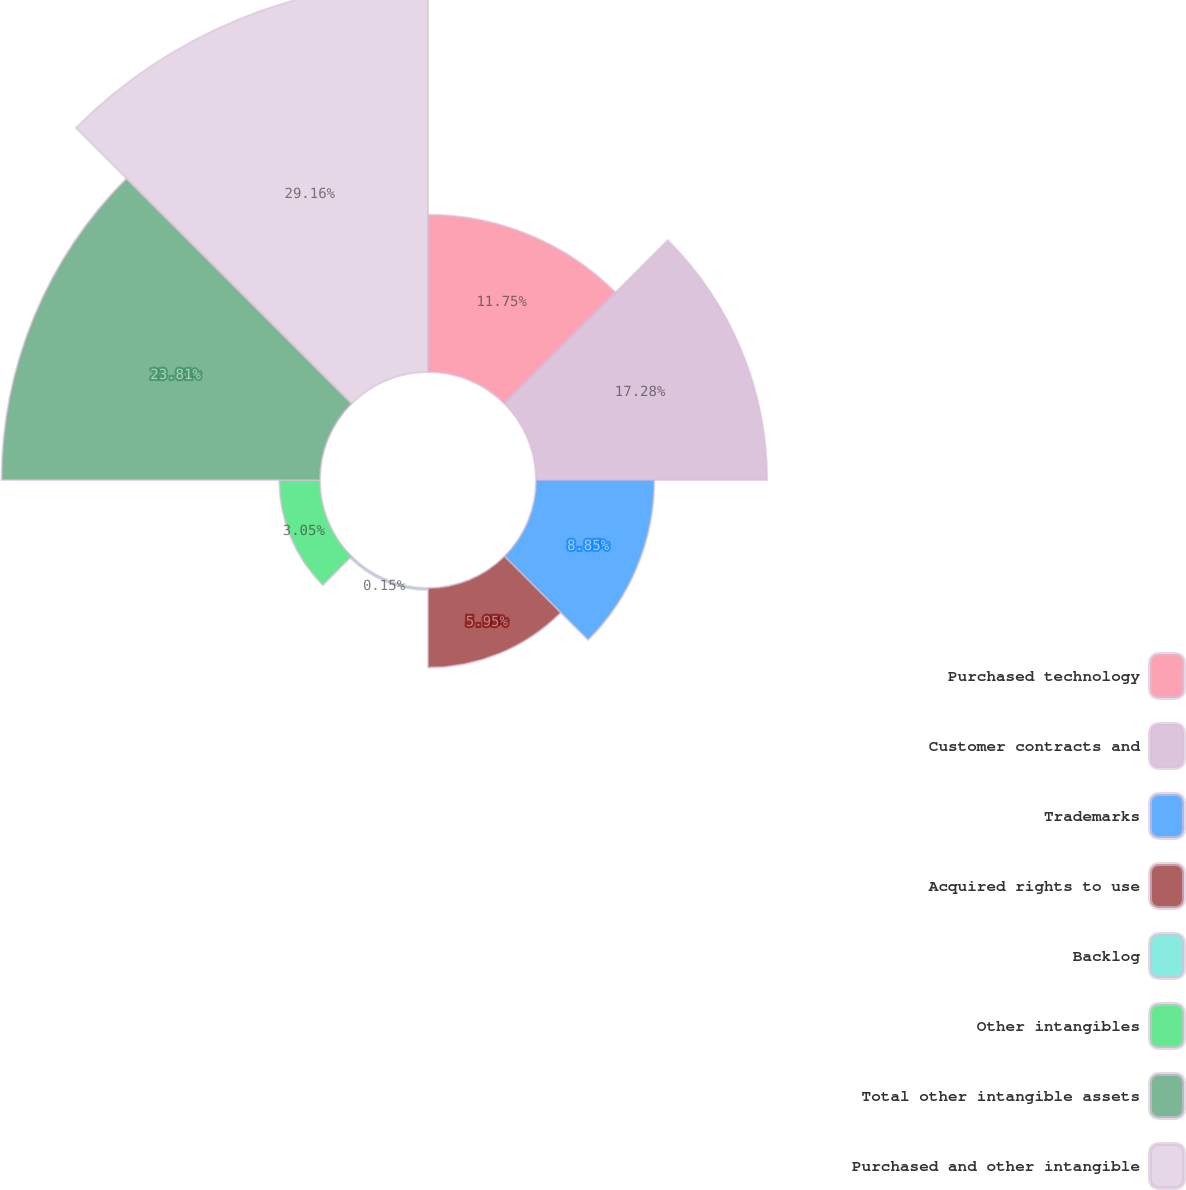<chart> <loc_0><loc_0><loc_500><loc_500><pie_chart><fcel>Purchased technology<fcel>Customer contracts and<fcel>Trademarks<fcel>Acquired rights to use<fcel>Backlog<fcel>Other intangibles<fcel>Total other intangible assets<fcel>Purchased and other intangible<nl><fcel>11.75%<fcel>17.28%<fcel>8.85%<fcel>5.95%<fcel>0.15%<fcel>3.05%<fcel>23.81%<fcel>29.16%<nl></chart> 